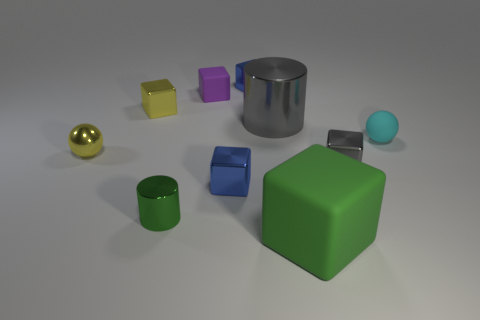Is there a purple rubber object of the same shape as the big gray thing?
Offer a terse response. No. What is the shape of the green shiny object that is the same size as the yellow block?
Provide a succinct answer. Cylinder. There is a big block; is its color the same as the small sphere behind the yellow metallic ball?
Your answer should be compact. No. There is a large thing in front of the small green metal cylinder; how many blue objects are on the right side of it?
Provide a succinct answer. 0. There is a shiny object that is left of the tiny green cylinder and to the right of the small metal sphere; what is its size?
Give a very brief answer. Small. Are there any green things of the same size as the green cube?
Offer a terse response. No. Are there more tiny gray metal cubes right of the cyan rubber ball than tiny blue metallic blocks that are to the right of the tiny cylinder?
Ensure brevity in your answer.  No. Are the tiny green cylinder and the blue block that is in front of the tiny gray object made of the same material?
Your answer should be very brief. Yes. There is a gray thing to the right of the green thing that is on the right side of the tiny rubber block; what number of tiny metal cubes are in front of it?
Provide a succinct answer. 1. Does the big metallic thing have the same shape as the green object that is behind the green matte thing?
Your answer should be very brief. Yes. 